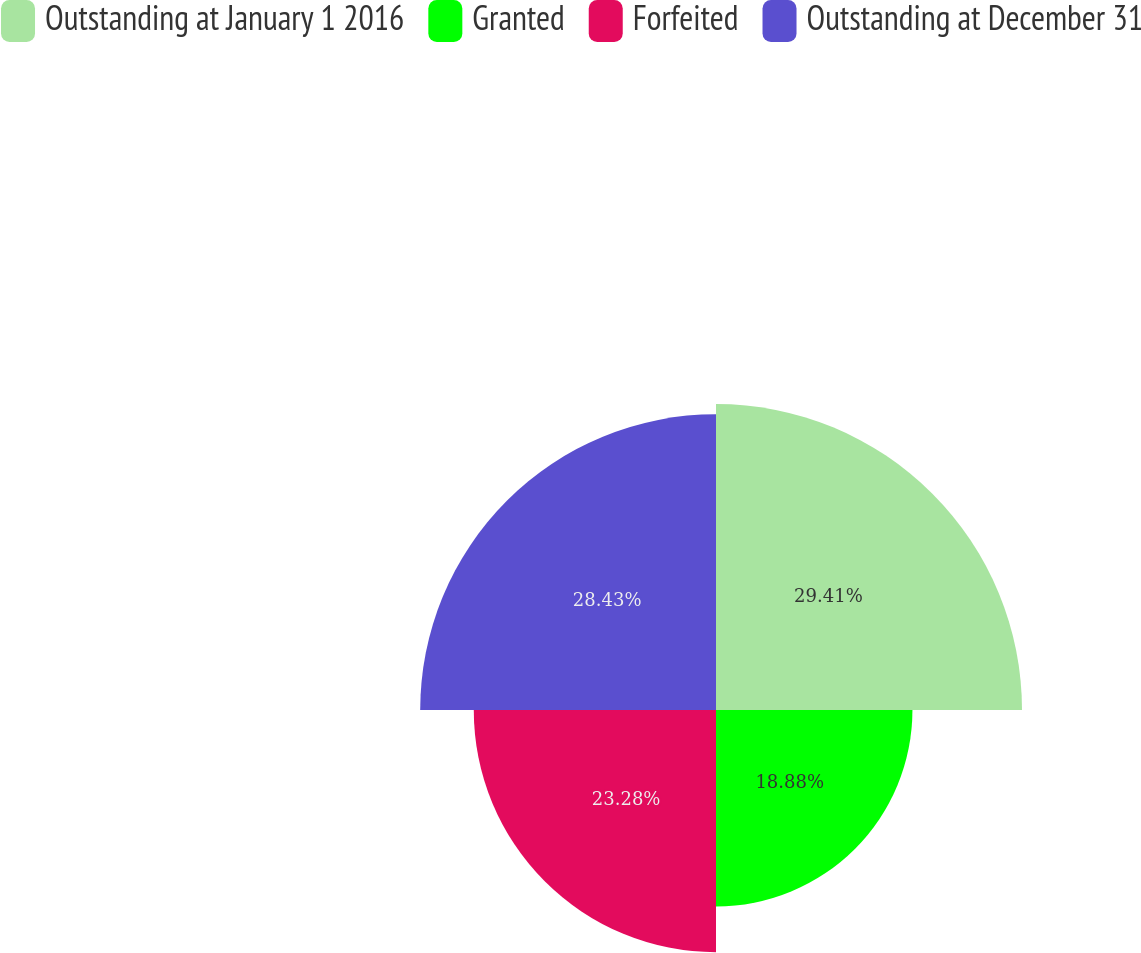Convert chart. <chart><loc_0><loc_0><loc_500><loc_500><pie_chart><fcel>Outstanding at January 1 2016<fcel>Granted<fcel>Forfeited<fcel>Outstanding at December 31<nl><fcel>29.41%<fcel>18.88%<fcel>23.28%<fcel>28.43%<nl></chart> 